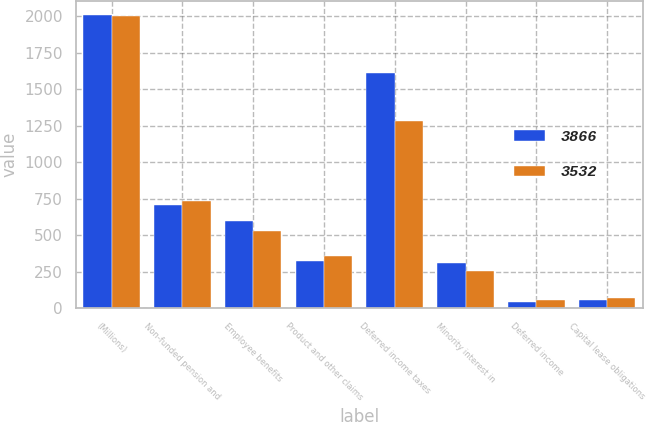<chart> <loc_0><loc_0><loc_500><loc_500><stacked_bar_chart><ecel><fcel>(Millions)<fcel>Non-funded pension and<fcel>Employee benefits<fcel>Product and other claims<fcel>Deferred income taxes<fcel>Minority interest in<fcel>Deferred income<fcel>Capital lease obligations<nl><fcel>3866<fcel>2005<fcel>710<fcel>595<fcel>322<fcel>1609<fcel>311<fcel>45<fcel>59<nl><fcel>3532<fcel>2004<fcel>737<fcel>530<fcel>356<fcel>1284<fcel>253<fcel>55<fcel>71<nl></chart> 